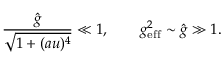<formula> <loc_0><loc_0><loc_500><loc_500>\frac { \hat { g } } { \sqrt { 1 + ( a u ) ^ { 4 } } } \ll 1 , \quad g _ { e f f } ^ { 2 } \sim \hat { g } \gg 1 .</formula> 